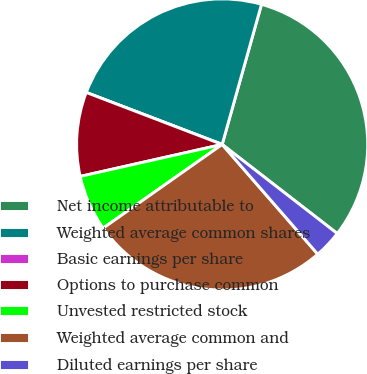Convert chart to OTSL. <chart><loc_0><loc_0><loc_500><loc_500><pie_chart><fcel>Net income attributable to<fcel>Weighted average common shares<fcel>Basic earnings per share<fcel>Options to purchase common<fcel>Unvested restricted stock<fcel>Weighted average common and<fcel>Diluted earnings per share<nl><fcel>31.13%<fcel>23.54%<fcel>0.0%<fcel>9.34%<fcel>6.23%<fcel>26.65%<fcel>3.11%<nl></chart> 